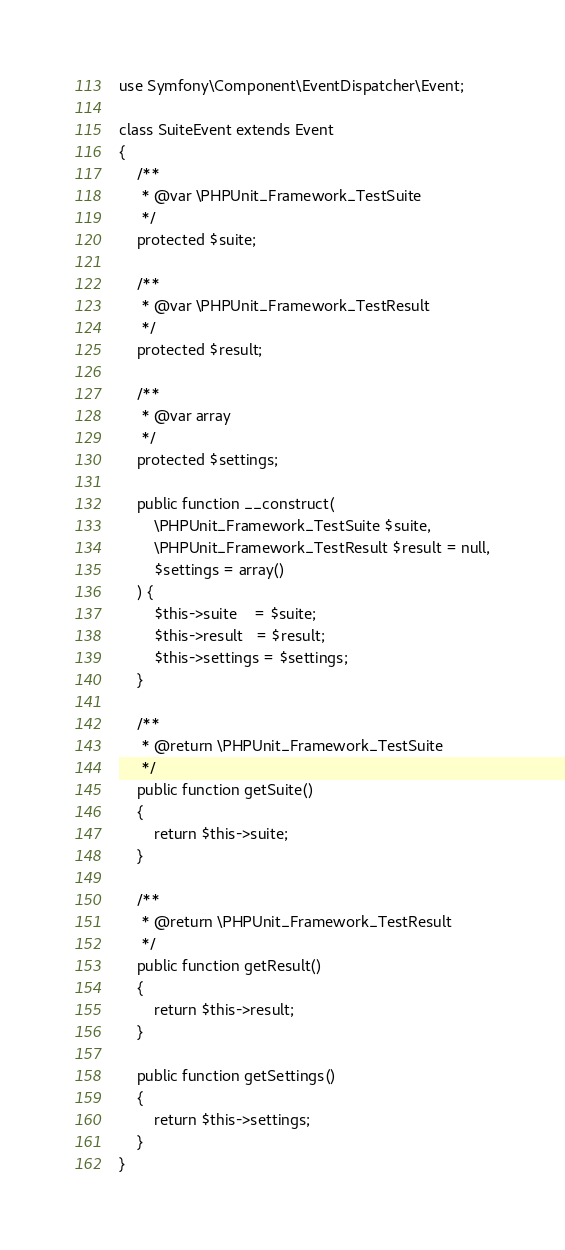Convert code to text. <code><loc_0><loc_0><loc_500><loc_500><_PHP_>use Symfony\Component\EventDispatcher\Event;

class SuiteEvent extends Event
{
    /**
     * @var \PHPUnit_Framework_TestSuite
     */
    protected $suite;

    /**
     * @var \PHPUnit_Framework_TestResult
     */
    protected $result;

    /**
     * @var array
     */
    protected $settings;

    public function __construct(
        \PHPUnit_Framework_TestSuite $suite,
        \PHPUnit_Framework_TestResult $result = null,
        $settings = array()
    ) {
        $this->suite    = $suite;
        $this->result   = $result;
        $this->settings = $settings;
    }

    /**
     * @return \PHPUnit_Framework_TestSuite
     */
    public function getSuite()
    {
        return $this->suite;
    }

    /**
     * @return \PHPUnit_Framework_TestResult
     */
    public function getResult()
    {
        return $this->result;
    }

    public function getSettings()
    {
        return $this->settings;
    }
}
</code> 